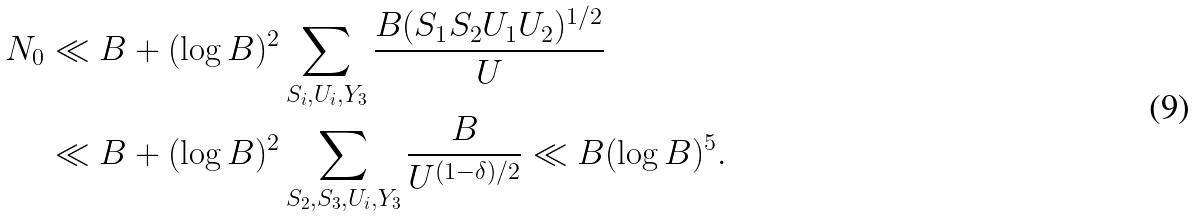Convert formula to latex. <formula><loc_0><loc_0><loc_500><loc_500>N _ { 0 } & \ll B + ( \log B ) ^ { 2 } \sum _ { S _ { i } , U _ { i } , Y _ { 3 } } \frac { B ( S _ { 1 } S _ { 2 } U _ { 1 } U _ { 2 } ) ^ { 1 / 2 } } { U } \\ & \ll B + ( \log B ) ^ { 2 } \sum _ { S _ { 2 } , S _ { 3 } , U _ { i } , Y _ { 3 } } \frac { B } { U ^ { ( 1 - \delta ) / 2 } } \ll B ( \log B ) ^ { 5 } .</formula> 